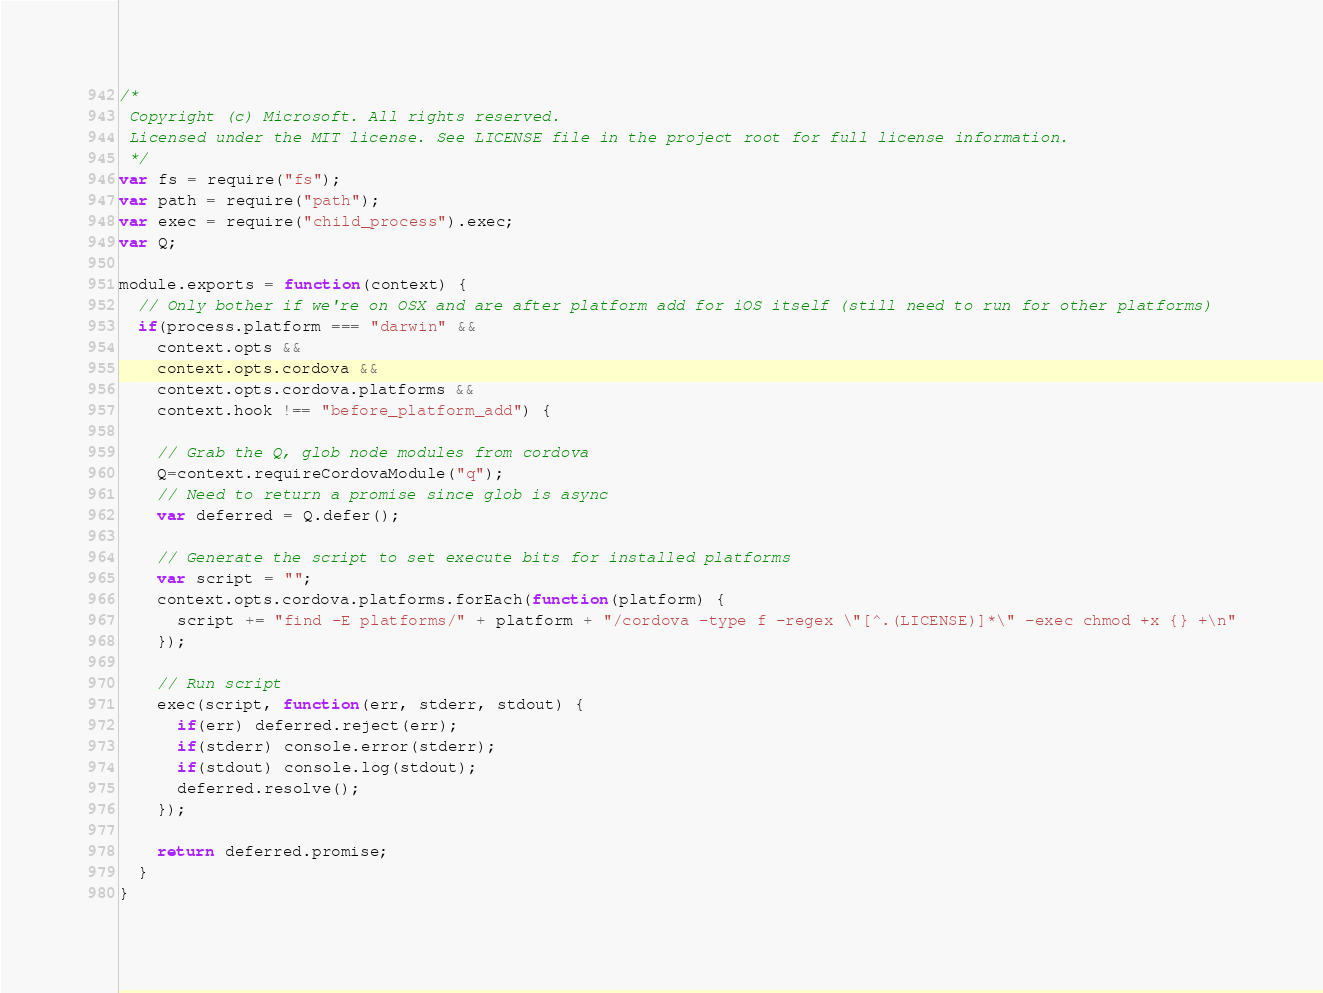<code> <loc_0><loc_0><loc_500><loc_500><_JavaScript_>/*
 Copyright (c) Microsoft. All rights reserved.
 Licensed under the MIT license. See LICENSE file in the project root for full license information.
 */
var fs = require("fs");
var path = require("path");
var exec = require("child_process").exec;
var Q;

module.exports = function(context) {
  // Only bother if we're on OSX and are after platform add for iOS itself (still need to run for other platforms)
  if(process.platform === "darwin" &&
    context.opts &&
    context.opts.cordova &&
    context.opts.cordova.platforms &&
    context.hook !== "before_platform_add") {

    // Grab the Q, glob node modules from cordova
    Q=context.requireCordovaModule("q");
    // Need to return a promise since glob is async
    var deferred = Q.defer();

    // Generate the script to set execute bits for installed platforms
    var script = "";
    context.opts.cordova.platforms.forEach(function(platform) {
      script += "find -E platforms/" + platform + "/cordova -type f -regex \"[^.(LICENSE)]*\" -exec chmod +x {} +\n"
    });

    // Run script
    exec(script, function(err, stderr, stdout) {
      if(err) deferred.reject(err);
      if(stderr) console.error(stderr);
      if(stdout) console.log(stdout);
      deferred.resolve();
    });

    return deferred.promise;
  }
}
</code> 